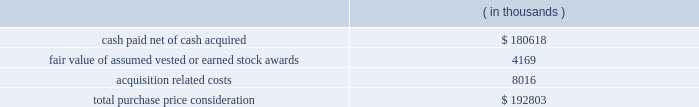Synopsys , inc .
Notes to consolidated financial statements 2014 ( continued ) and other electronic applications markets .
The company believes the acquisition will expand its technology portfolio , channel reach and total addressable market by adding complementary products and expertise for fpga solutions and rapid asic prototyping .
Purchase price .
Synopsys paid $ 8.00 per share for all outstanding shares including certain vested options of synplicity for an aggregate cash payment of $ 223.3 million .
Additionally , synopsys assumed certain employee stock options and restricted stock units , collectively called 201cstock awards . 201d the total purchase consideration consisted of: .
Acquisition related costs consist primarily of professional services , severance and employee related costs and facilities closure costs of which $ 6.8 million have been paid as of october 31 , 2009 .
Fair value of stock awards assumed .
An aggregate of 4.7 million shares of synplicity stock options and restricted stock units were exchanged for synopsys stock options and restricted stock units at an exchange ratio of 0.3392 per share .
The fair value of stock options assumed was determined using a black-scholes valuation model .
The fair value of stock awards vested or earned of $ 4.2 million was included as part of the purchase price .
The fair value of unvested awards of $ 5.0 million will be recorded as operating expense over the remaining service periods on a straight-line basis .
Purchase price allocation .
The company allocated $ 80.0 million of the purchase price to identifiable intangible assets to be amortized over two to seven years .
In-process research and development expense related to these acquisitions was $ 4.8 million .
Goodwill , representing the excess of the purchase price over the fair value of tangible and identifiable intangible assets acquired , was $ 120.3 million and will not be amortized .
Goodwill primarily resulted from the company 2019s expectation of cost synergies and sales growth from the integration of synplicity 2019s technology with the company 2019s technology and operations to provide an expansion of products and market reach .
Fiscal 2007 acquisitions during fiscal year 2007 , the company completed certain purchase acquisitions for cash .
The company allocated the total purchase considerations of $ 54.8 million ( which included acquisition related costs of $ 1.4 million ) to the assets and liabilities acquired , including identifiable intangible assets , based on their respective fair values at the acquisition dates , resulting in aggregate goodwill of $ 36.6 million .
Acquired identifiable intangible assets of $ 14.3 million are being amortized over two to nine years .
In-process research and development expense related to these acquisitions was $ 3.2 million. .
What percentage of the total purchase price consideration is represented by goodwill? 
Computations: ((120.3 * 1000) / 192803)
Answer: 0.62395. 